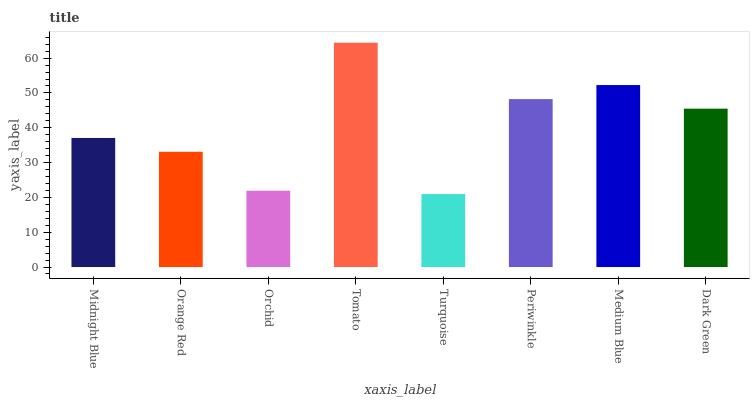Is Turquoise the minimum?
Answer yes or no. Yes. Is Tomato the maximum?
Answer yes or no. Yes. Is Orange Red the minimum?
Answer yes or no. No. Is Orange Red the maximum?
Answer yes or no. No. Is Midnight Blue greater than Orange Red?
Answer yes or no. Yes. Is Orange Red less than Midnight Blue?
Answer yes or no. Yes. Is Orange Red greater than Midnight Blue?
Answer yes or no. No. Is Midnight Blue less than Orange Red?
Answer yes or no. No. Is Dark Green the high median?
Answer yes or no. Yes. Is Midnight Blue the low median?
Answer yes or no. Yes. Is Medium Blue the high median?
Answer yes or no. No. Is Medium Blue the low median?
Answer yes or no. No. 